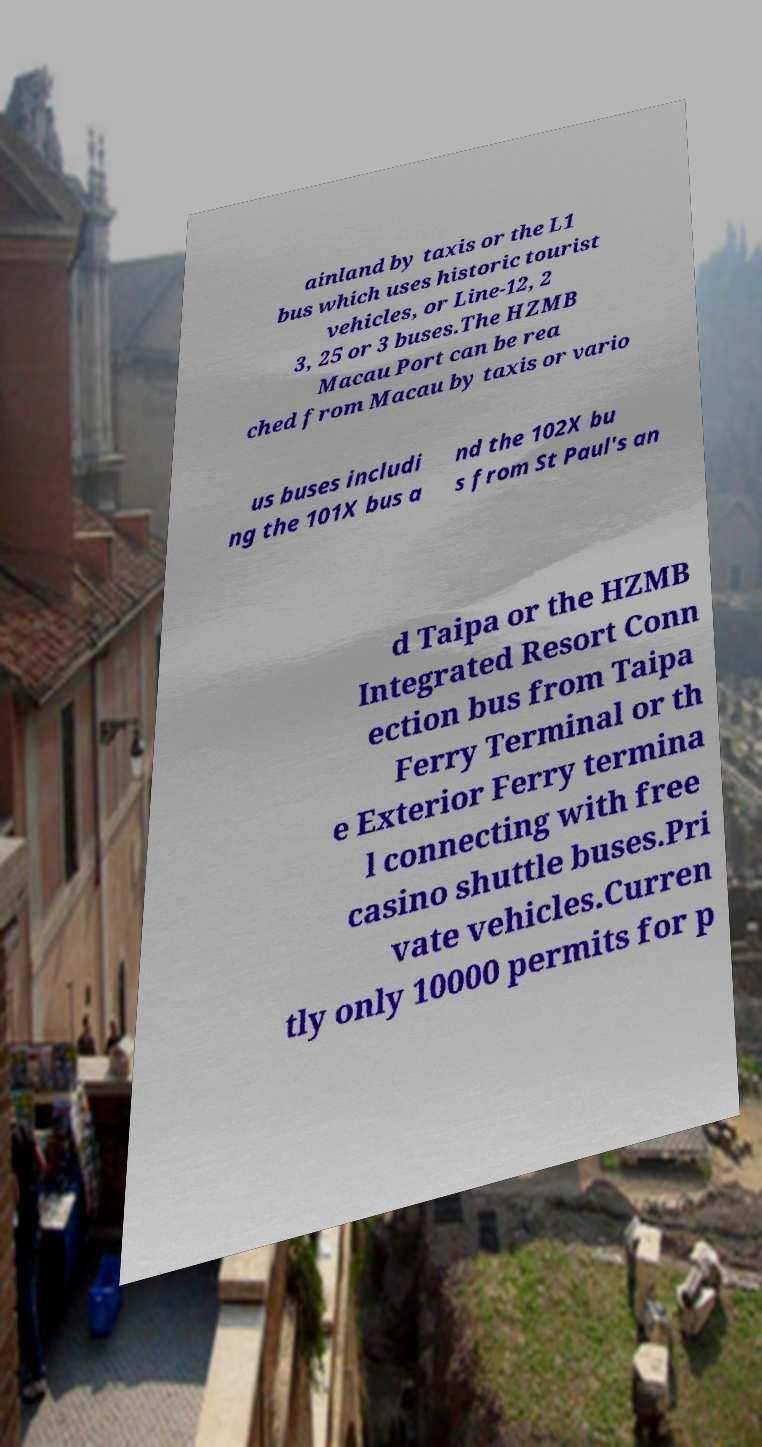What messages or text are displayed in this image? I need them in a readable, typed format. ainland by taxis or the L1 bus which uses historic tourist vehicles, or Line-12, 2 3, 25 or 3 buses.The HZMB Macau Port can be rea ched from Macau by taxis or vario us buses includi ng the 101X bus a nd the 102X bu s from St Paul's an d Taipa or the HZMB Integrated Resort Conn ection bus from Taipa Ferry Terminal or th e Exterior Ferry termina l connecting with free casino shuttle buses.Pri vate vehicles.Curren tly only 10000 permits for p 